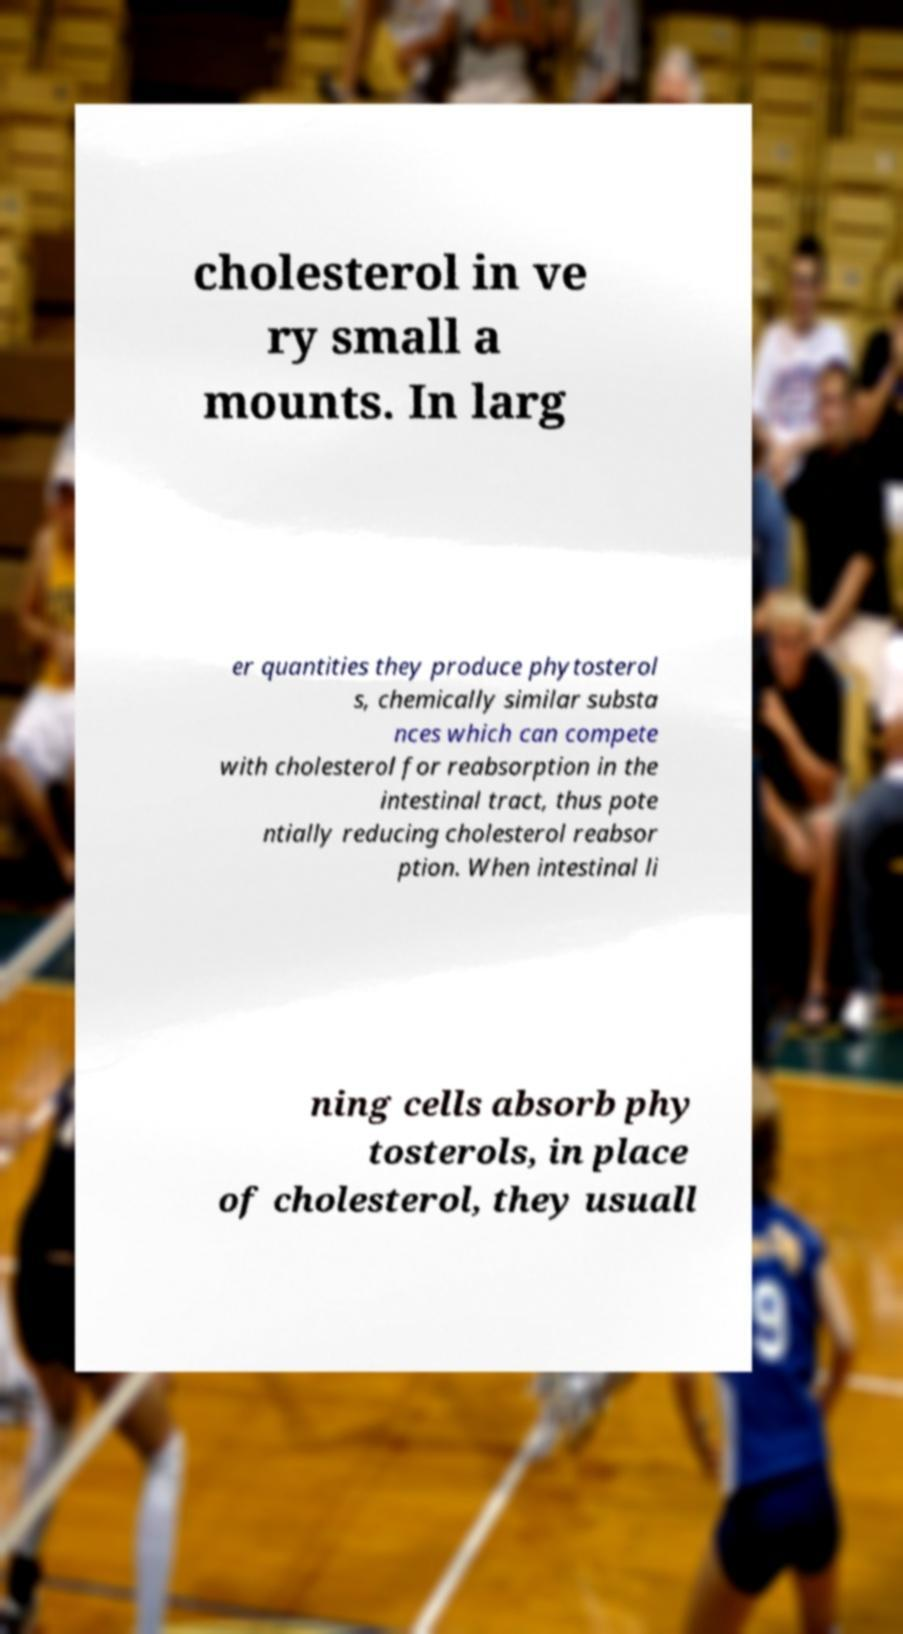There's text embedded in this image that I need extracted. Can you transcribe it verbatim? cholesterol in ve ry small a mounts. In larg er quantities they produce phytosterol s, chemically similar substa nces which can compete with cholesterol for reabsorption in the intestinal tract, thus pote ntially reducing cholesterol reabsor ption. When intestinal li ning cells absorb phy tosterols, in place of cholesterol, they usuall 